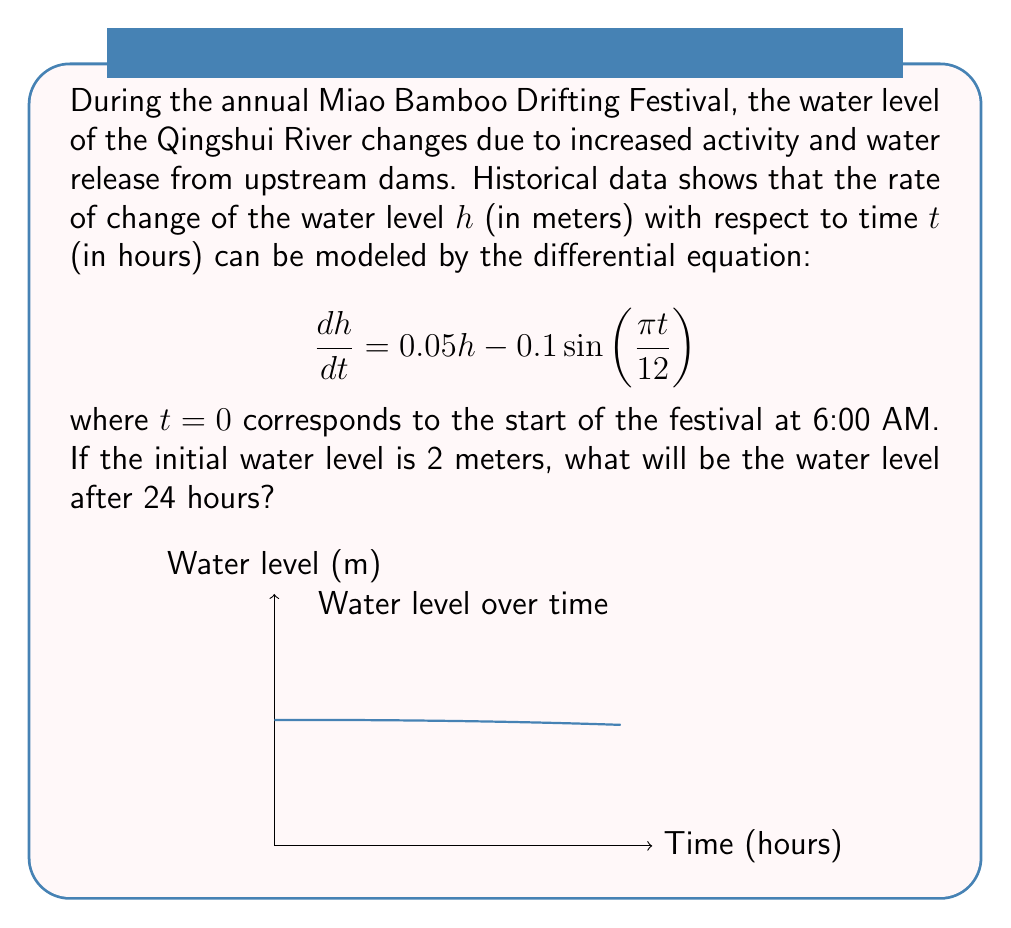Give your solution to this math problem. To solve this problem, we'll follow these steps:

1) The given differential equation is:

   $$\frac{dh}{dt} = 0.05h - 0.1\sin(\frac{\pi t}{12})$$

2) This is a linear first-order differential equation. We can solve it using the integrating factor method.

3) The integrating factor is $e^{-\int 0.05 dt} = e^{-0.05t}$.

4) Multiplying both sides of the equation by the integrating factor:

   $$e^{-0.05t}\frac{dh}{dt} - 0.05e^{-0.05t}h = -0.1e^{-0.05t}\sin(\frac{\pi t}{12})$$

5) The left side is now the derivative of $e^{-0.05t}h$. So we can write:

   $$\frac{d}{dt}(e^{-0.05t}h) = -0.1e^{-0.05t}\sin(\frac{\pi t}{12})$$

6) Integrating both sides:

   $$e^{-0.05t}h = -0.1\int e^{-0.05t}\sin(\frac{\pi t}{12})dt + C$$

7) Solving for $h$:

   $$h = -0.1e^{0.05t}\int e^{-0.05t}\sin(\frac{\pi t}{12})dt + Ce^{0.05t}$$

8) Using the initial condition $h(0) = 2$, we can find $C = 2$.

9) The final solution is:

   $$h = 2e^{0.05t} - 0.1e^{0.05t}\int_0^t e^{-0.05s}\sin(\frac{\pi s}{12})ds$$

10) To find the water level after 24 hours, we need to evaluate this at $t = 24$:

    $$h(24) = 2e^{0.05(24)} - 0.1e^{0.05(24)}\int_0^{24} e^{-0.05s}\sin(\frac{\pi s}{12})ds$$

11) This integral doesn't have a simple closed form, so we need to evaluate it numerically. Using a computational tool, we get:

    $$h(24) \approx 3.32 \text{ meters}$$
Answer: 3.32 meters 